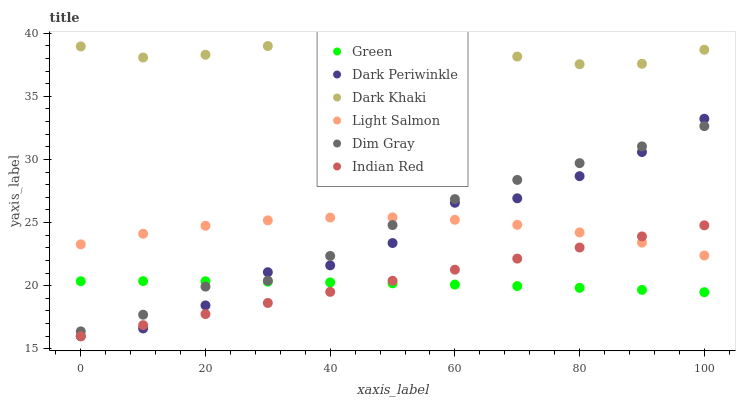Does Green have the minimum area under the curve?
Answer yes or no. Yes. Does Dark Khaki have the maximum area under the curve?
Answer yes or no. Yes. Does Dim Gray have the minimum area under the curve?
Answer yes or no. No. Does Dim Gray have the maximum area under the curve?
Answer yes or no. No. Is Indian Red the smoothest?
Answer yes or no. Yes. Is Dark Periwinkle the roughest?
Answer yes or no. Yes. Is Dim Gray the smoothest?
Answer yes or no. No. Is Dim Gray the roughest?
Answer yes or no. No. Does Indian Red have the lowest value?
Answer yes or no. Yes. Does Dim Gray have the lowest value?
Answer yes or no. No. Does Dark Khaki have the highest value?
Answer yes or no. Yes. Does Dim Gray have the highest value?
Answer yes or no. No. Is Dim Gray less than Dark Khaki?
Answer yes or no. Yes. Is Dim Gray greater than Indian Red?
Answer yes or no. Yes. Does Dark Periwinkle intersect Dim Gray?
Answer yes or no. Yes. Is Dark Periwinkle less than Dim Gray?
Answer yes or no. No. Is Dark Periwinkle greater than Dim Gray?
Answer yes or no. No. Does Dim Gray intersect Dark Khaki?
Answer yes or no. No. 